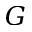Convert formula to latex. <formula><loc_0><loc_0><loc_500><loc_500>G</formula> 